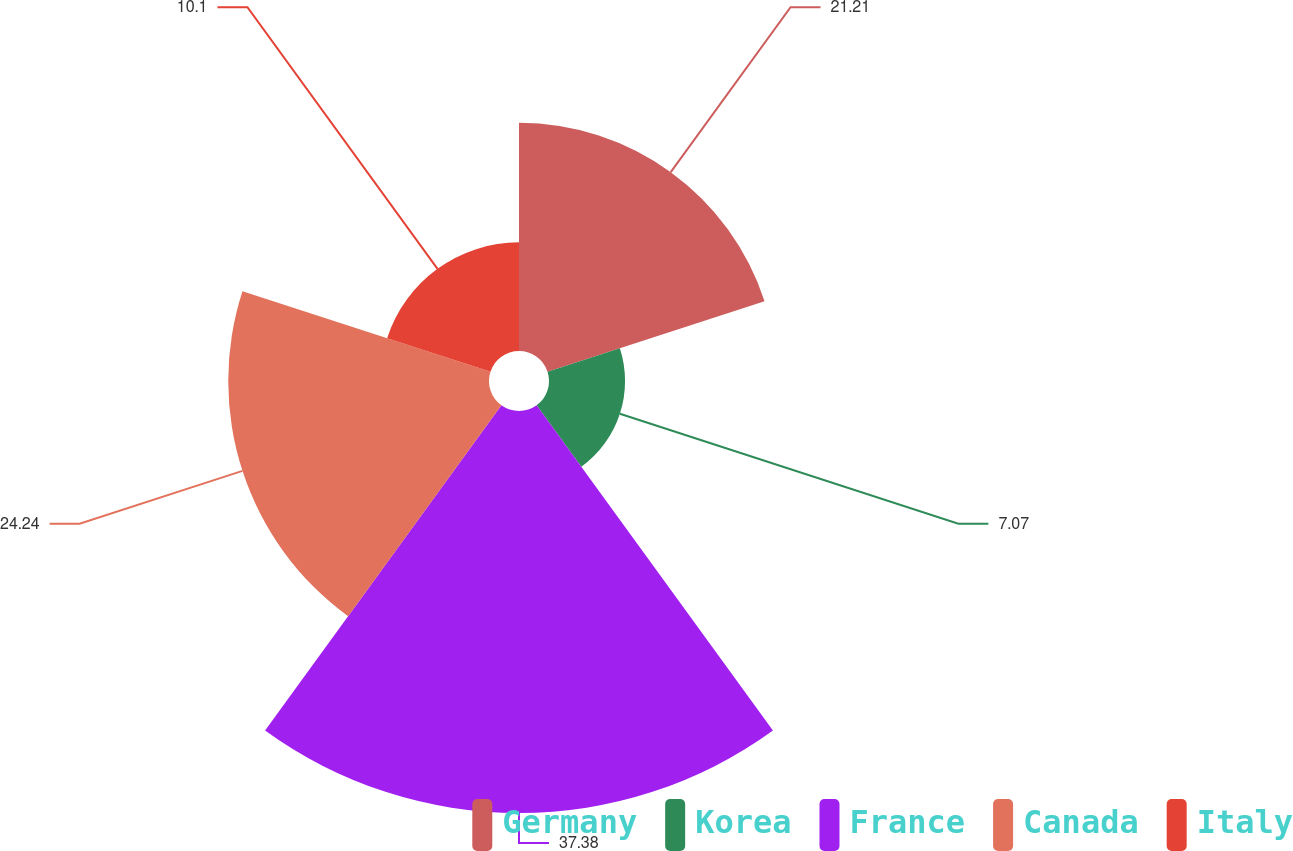<chart> <loc_0><loc_0><loc_500><loc_500><pie_chart><fcel>Germany<fcel>Korea<fcel>France<fcel>Canada<fcel>Italy<nl><fcel>21.21%<fcel>7.07%<fcel>37.37%<fcel>24.24%<fcel>10.1%<nl></chart> 